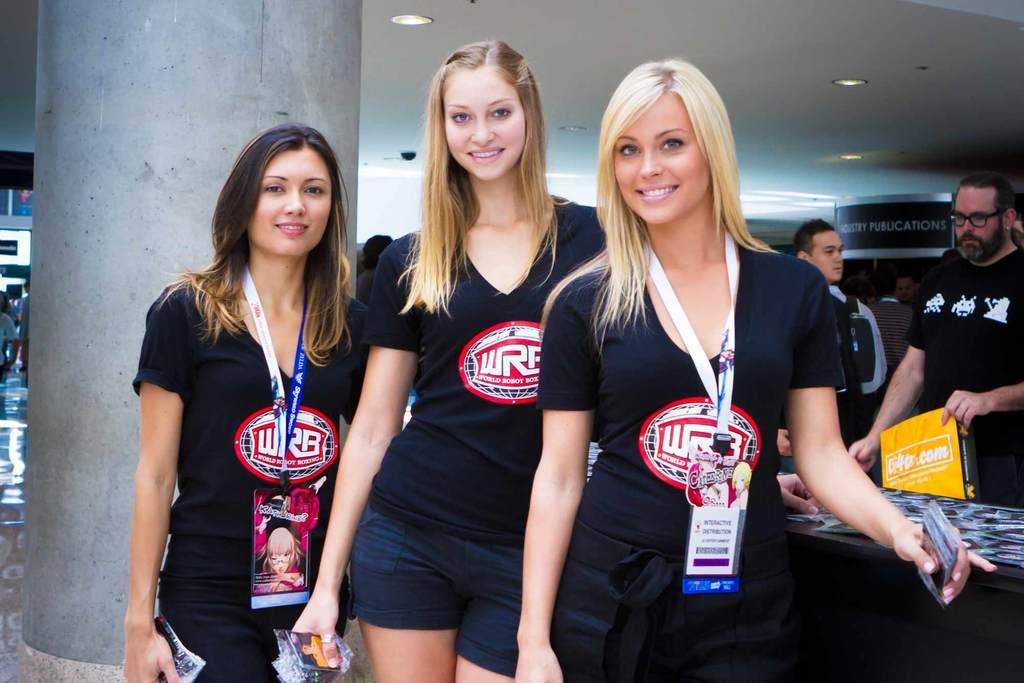<image>
Summarize the visual content of the image. Three girls are wearing matching shirts that say WRB. 